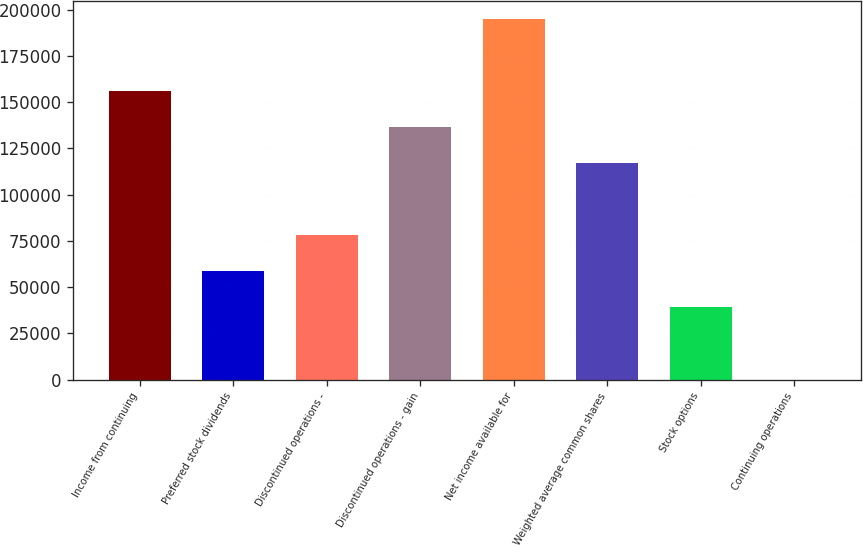Convert chart to OTSL. <chart><loc_0><loc_0><loc_500><loc_500><bar_chart><fcel>Income from continuing<fcel>Preferred stock dividends<fcel>Discontinued operations -<fcel>Discontinued operations - gain<fcel>Net income available for<fcel>Weighted average common shares<fcel>Stock options<fcel>Continuing operations<nl><fcel>156076<fcel>58529.7<fcel>78039<fcel>136567<fcel>195095<fcel>117058<fcel>39020.4<fcel>1.71<nl></chart> 